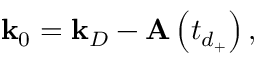Convert formula to latex. <formula><loc_0><loc_0><loc_500><loc_500>k _ { 0 } = k _ { D } - A \left ( t _ { d _ { + } } \right ) ,</formula> 